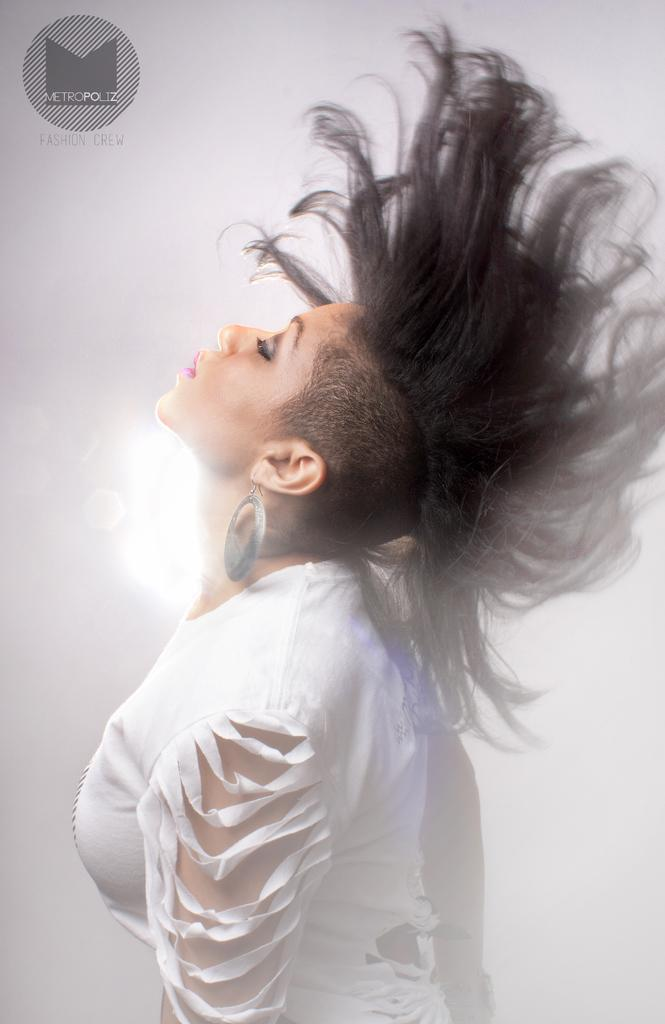Who or what is the main subject in the image? There is a person in the image. What is the person wearing? The person is wearing a white dress. What can be seen in the background of the image? The background of the image is white. What type of bone is visible in the image? There is no bone present in the image. What activity is the person engaged in within the image? The provided facts do not mention any specific activity the person is engaged in. 